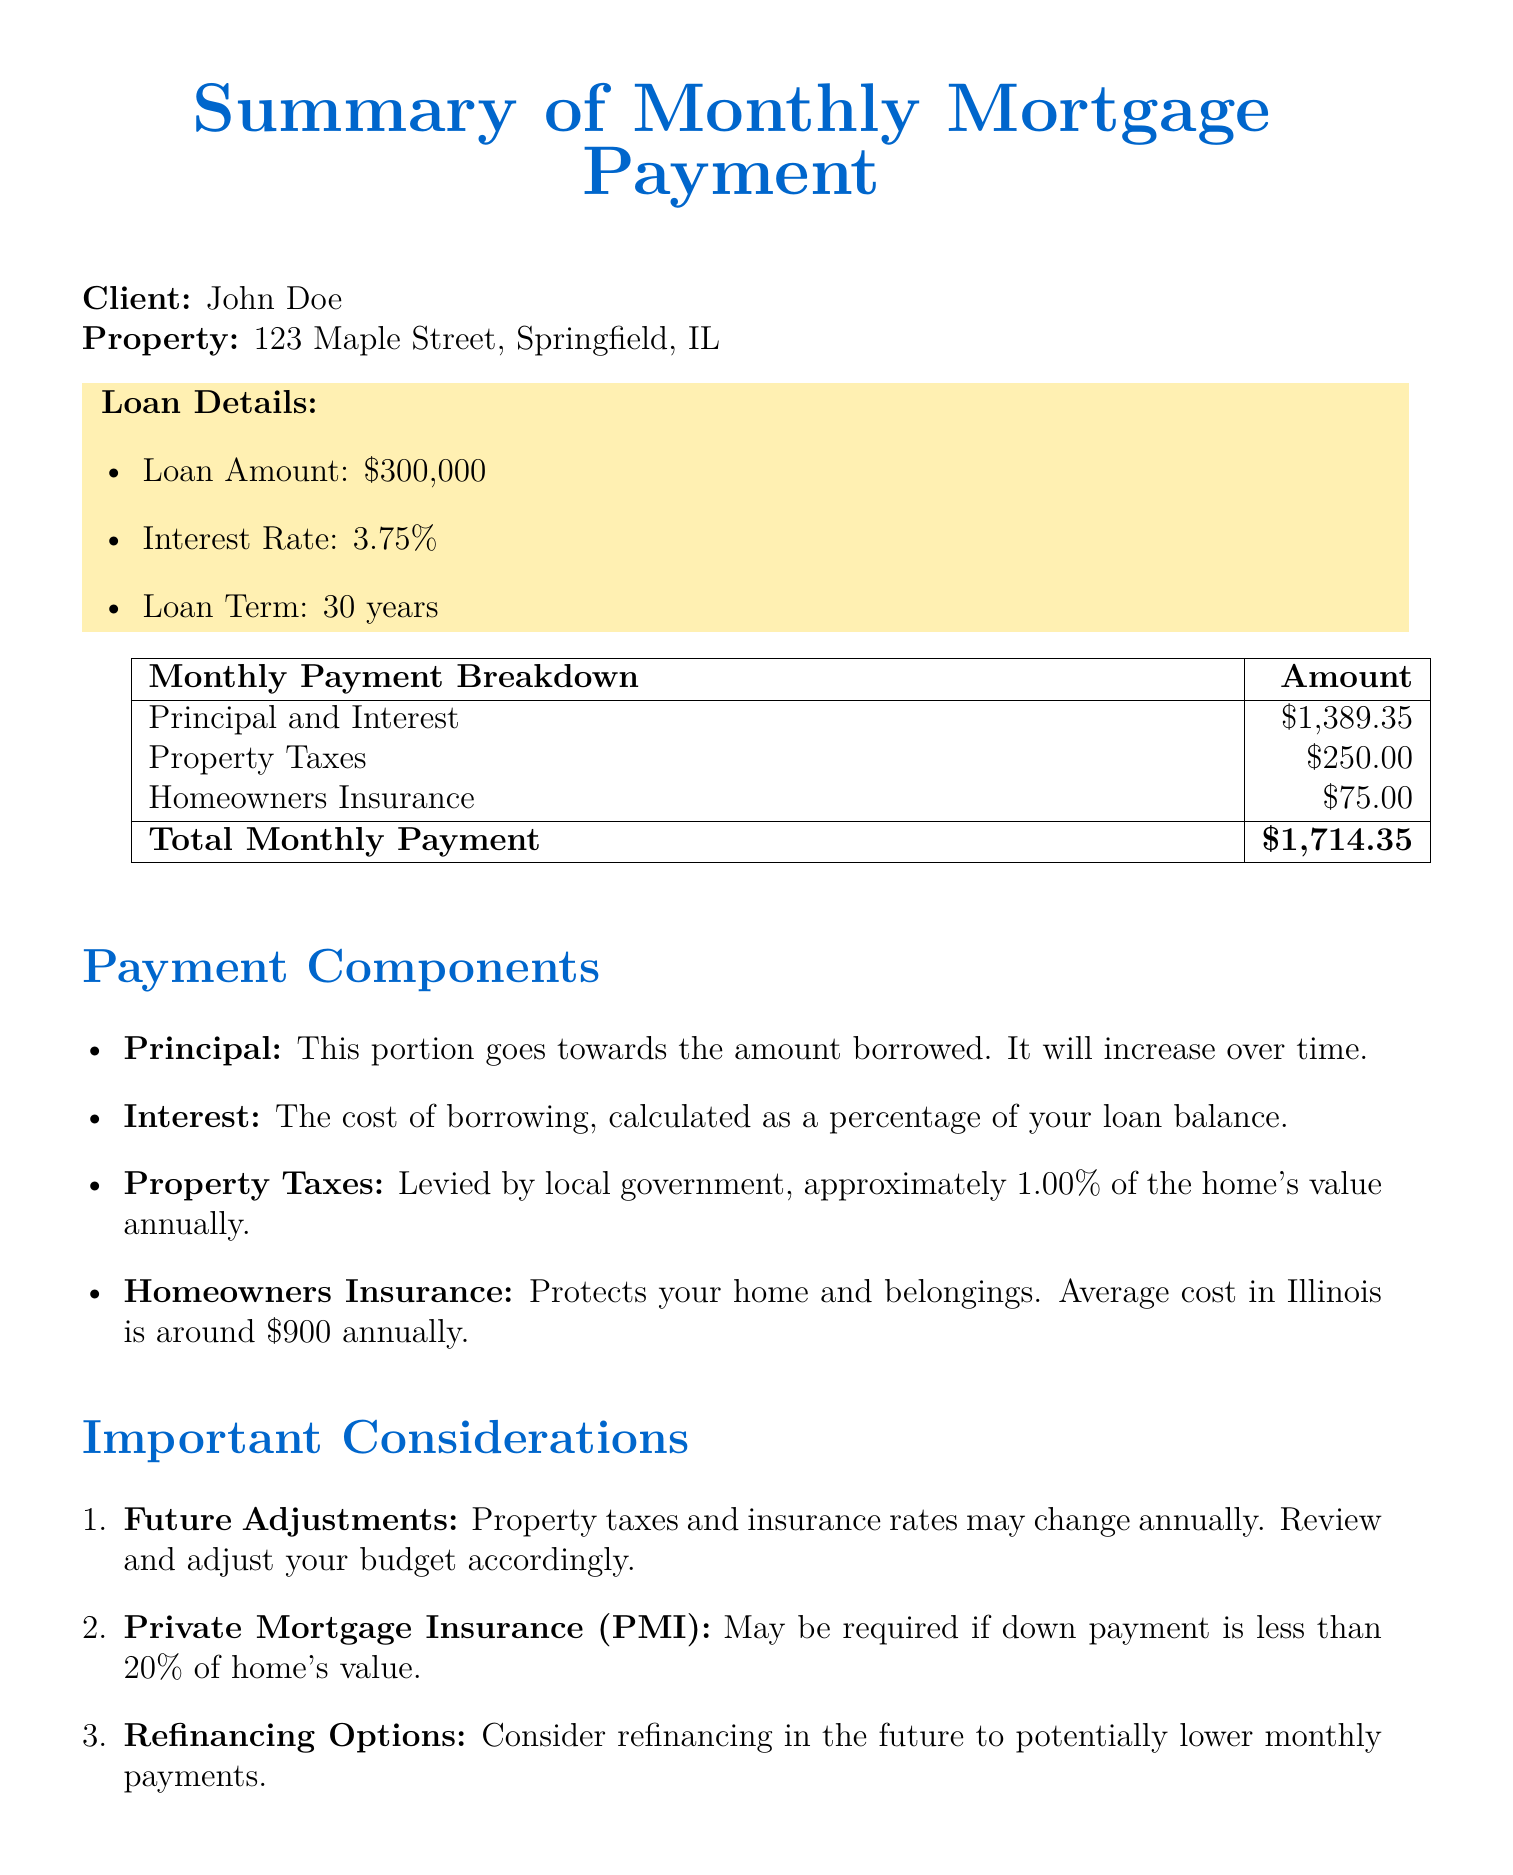What is the loan amount? The loan amount is specified in the document as $300,000.
Answer: $300,000 What is the interest rate? The interest rate is listed in the document as 3.75%.
Answer: 3.75% What is the property address? The property address is provided in the document as 123 Maple Street, Springfield, IL.
Answer: 123 Maple Street, Springfield, IL How much is allocated for property taxes? The document specifies that property taxes are $250.00 per month.
Answer: $250.00 What is the total monthly payment? The total monthly payment is the sum of all components, which is $1,714.35.
Answer: $1,714.35 What portion of the monthly payment goes towards homeowners insurance? The homeowners insurance cost is mentioned in the document as $75.00.
Answer: $75.00 Why might property taxes change? The document notes that property taxes may change annually, affecting your budget.
Answer: Change annually What should be considered if the down payment is less than 20%? The document mentions that Private Mortgage Insurance (PMI) may be required in this scenario.
Answer: PMI Who is the contact person for further information? The contact person listed in the document is Jane Smith.
Answer: Jane Smith What is the average annual cost of homeowners insurance in Illinois? The document states the average cost is around $900 annually.
Answer: $900 